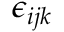<formula> <loc_0><loc_0><loc_500><loc_500>\epsilon _ { i j k }</formula> 